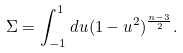Convert formula to latex. <formula><loc_0><loc_0><loc_500><loc_500>\Sigma = \int _ { - 1 } ^ { 1 } d u ( 1 - u ^ { 2 } ) ^ { \frac { n - 3 } { 2 } } .</formula> 